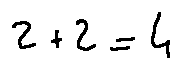<formula> <loc_0><loc_0><loc_500><loc_500>2 + 2 = 4</formula> 